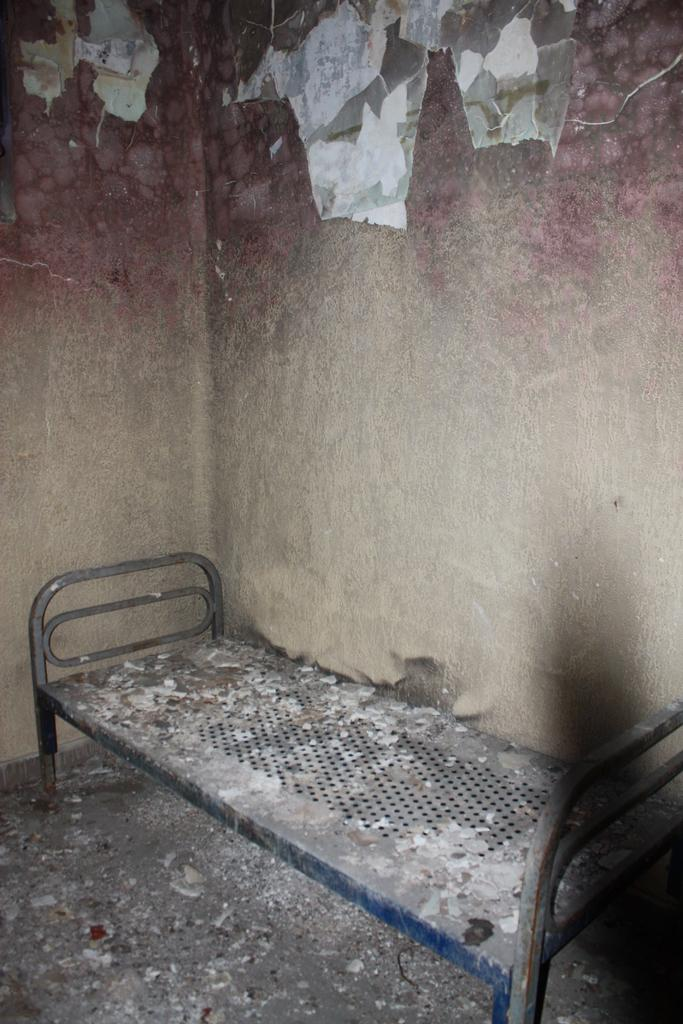What type of furniture is present in the image? There is a cot in the image. What is the condition of the walls in the image? The walls in the image are collapsed. What type of jeans can be seen hanging on the cot in the image? There are no jeans present in the image; only a cot and collapsed walls are visible. 